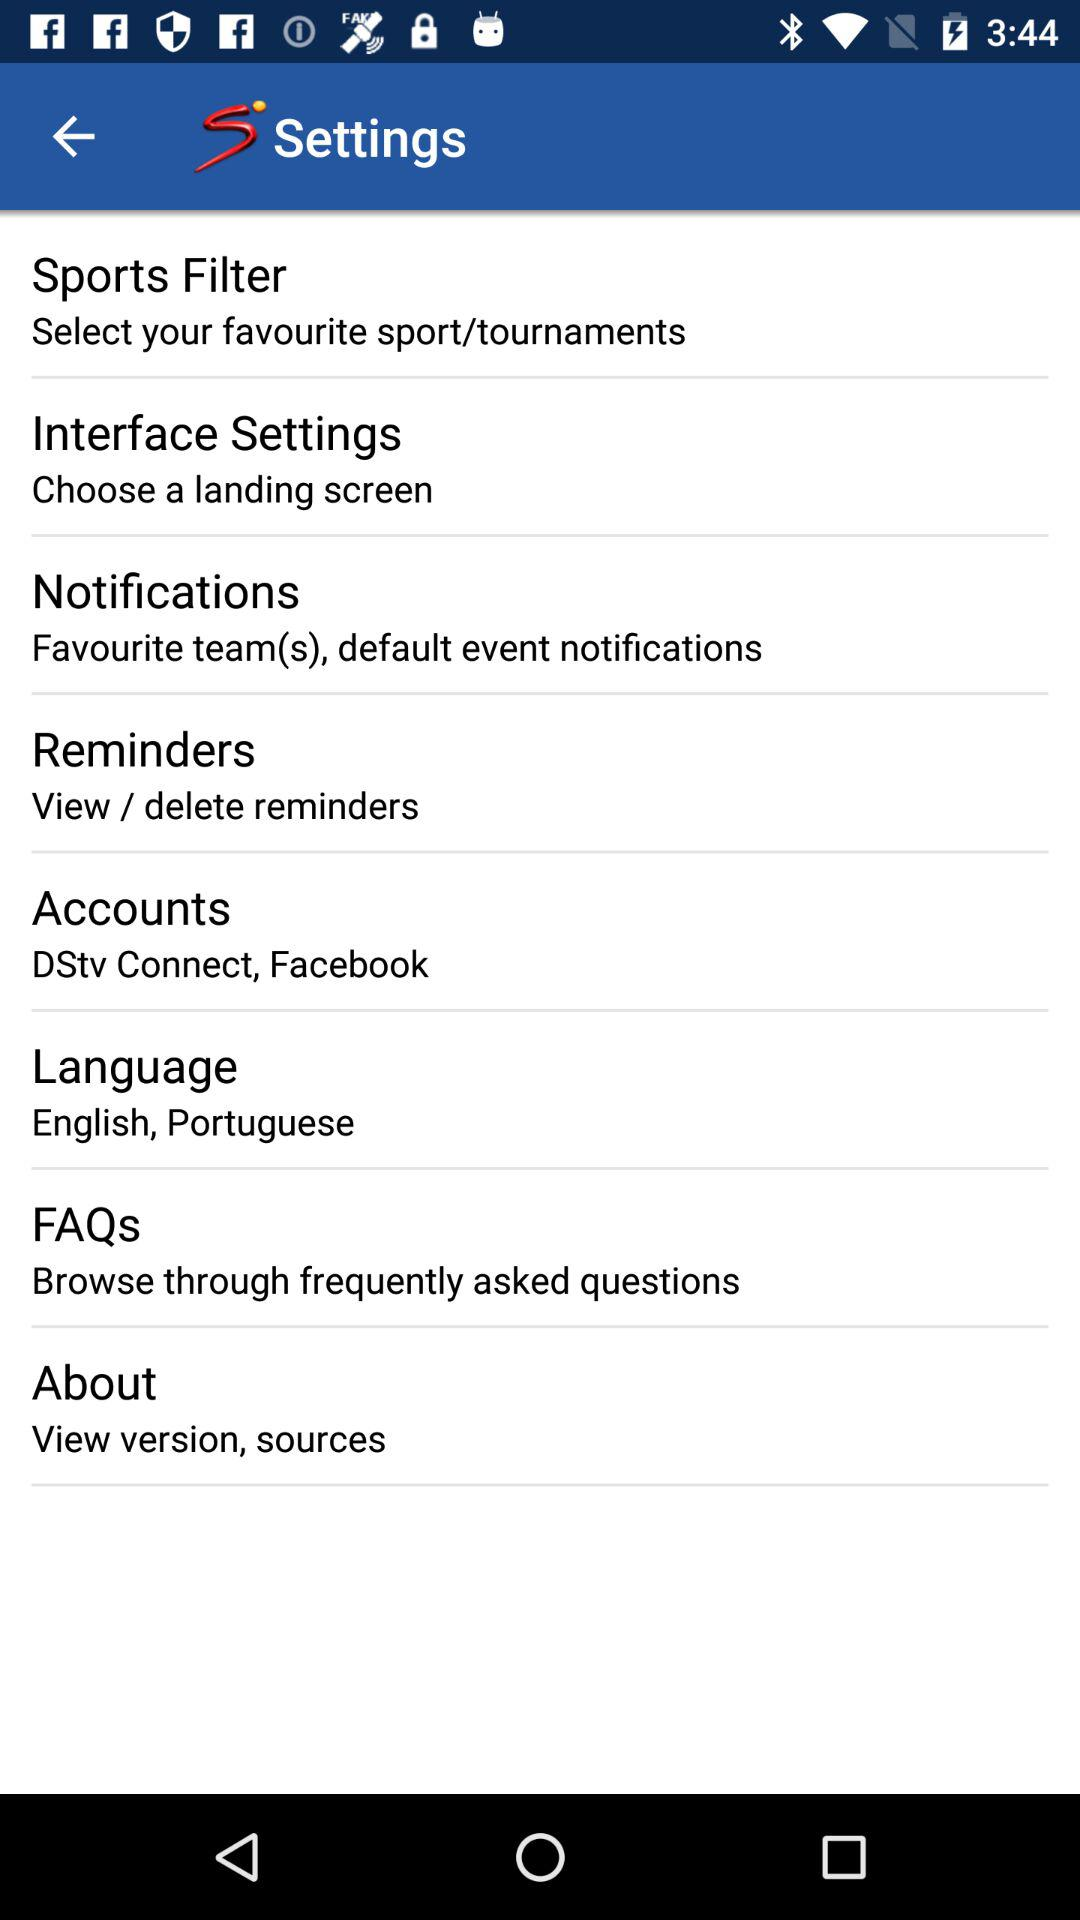What accounts are shown? The shown accounts are "DStv Connect" and "Facebook". 